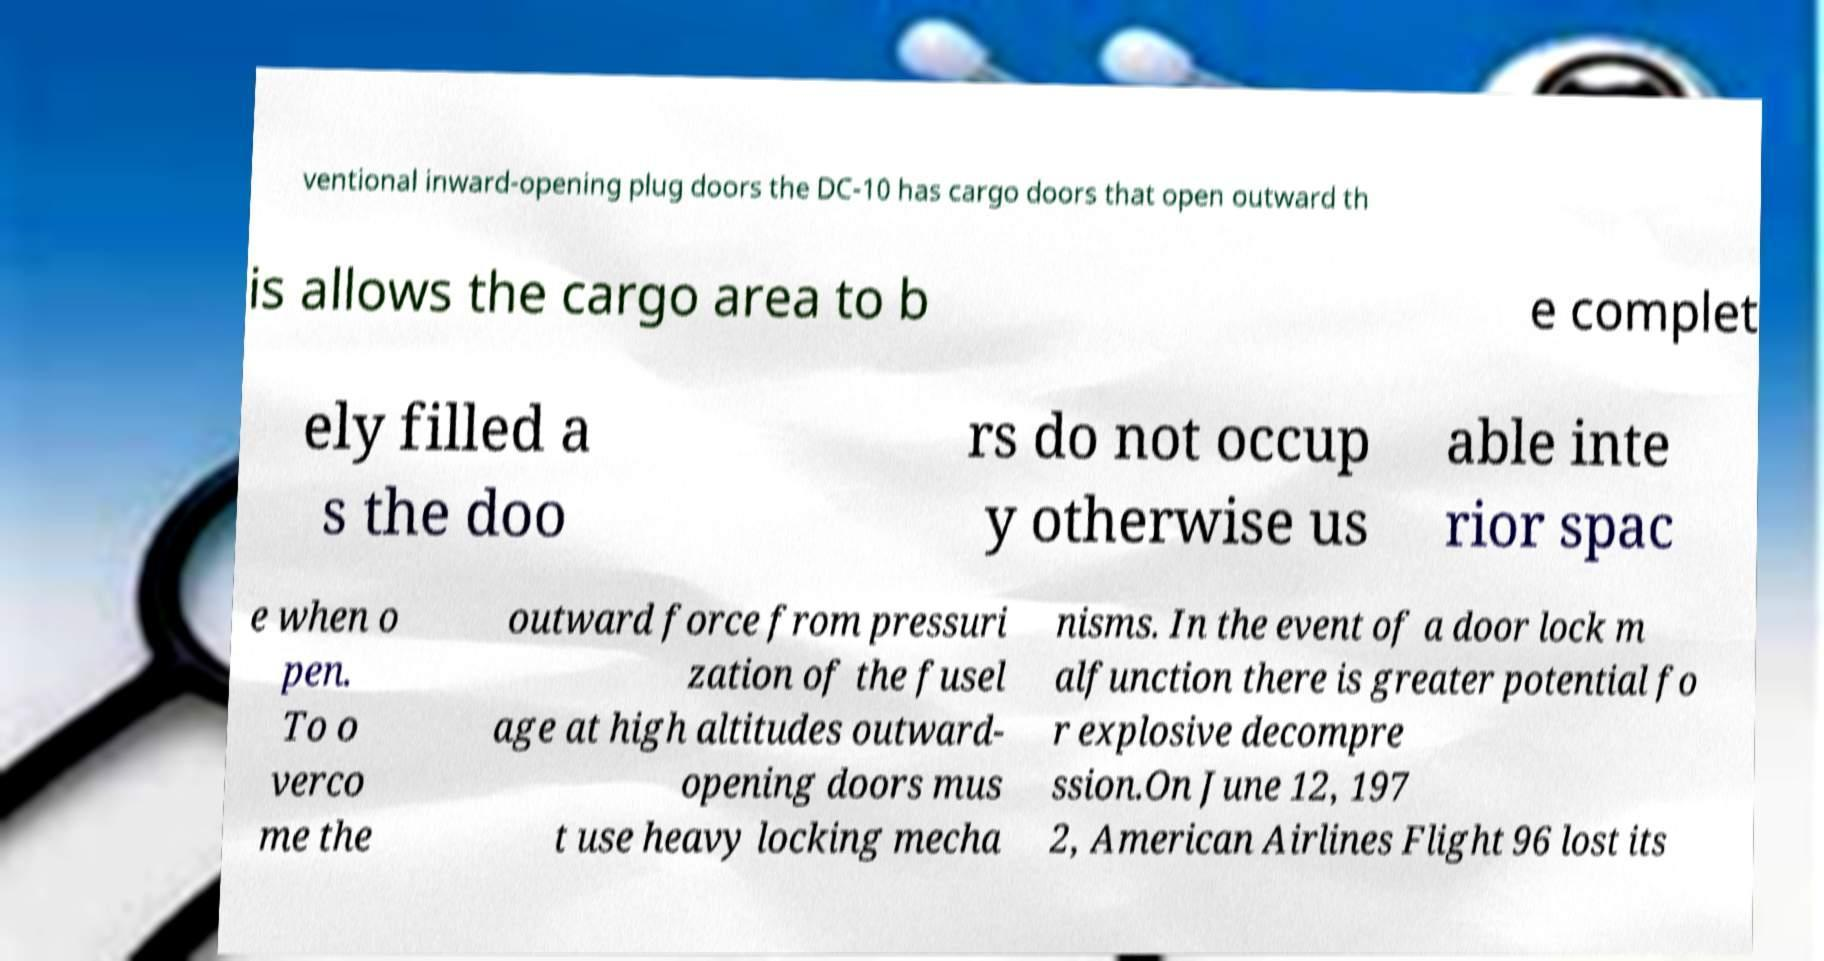Can you accurately transcribe the text from the provided image for me? ventional inward-opening plug doors the DC-10 has cargo doors that open outward th is allows the cargo area to b e complet ely filled a s the doo rs do not occup y otherwise us able inte rior spac e when o pen. To o verco me the outward force from pressuri zation of the fusel age at high altitudes outward- opening doors mus t use heavy locking mecha nisms. In the event of a door lock m alfunction there is greater potential fo r explosive decompre ssion.On June 12, 197 2, American Airlines Flight 96 lost its 